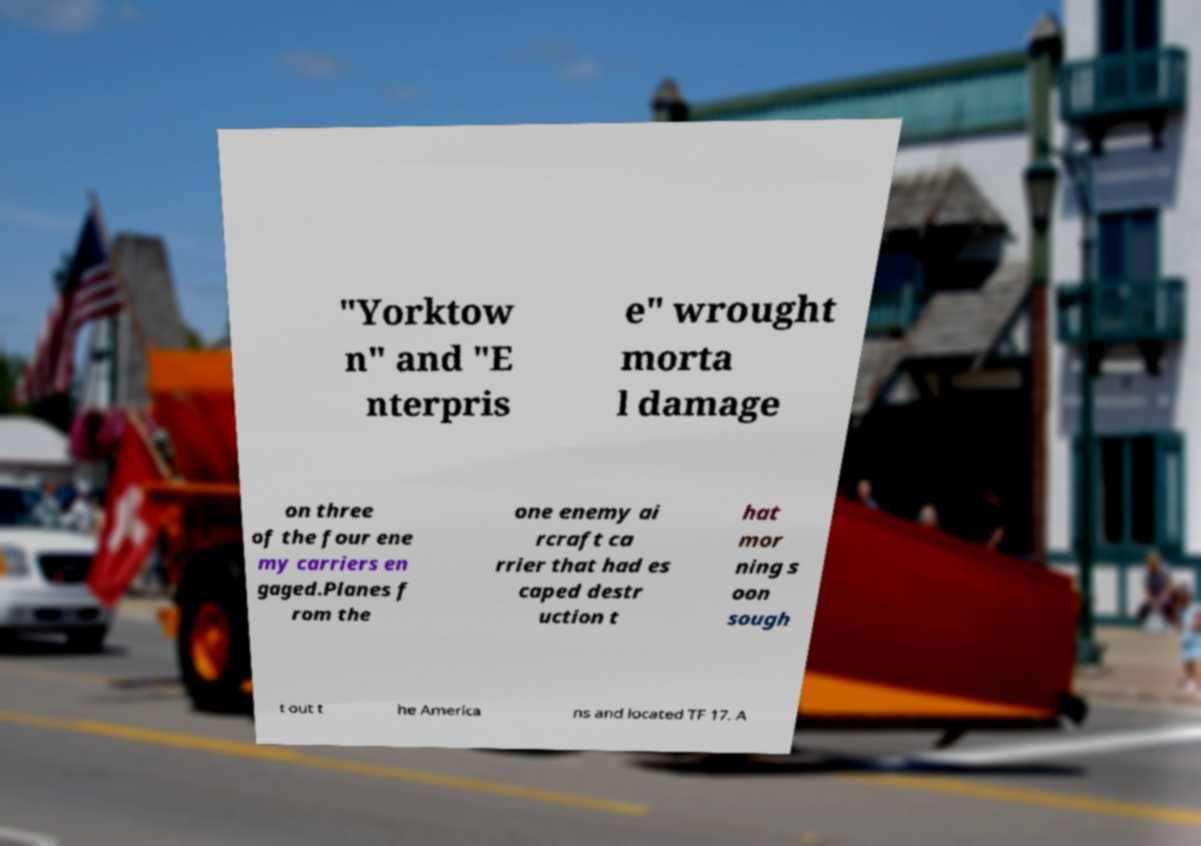For documentation purposes, I need the text within this image transcribed. Could you provide that? "Yorktow n" and "E nterpris e" wrought morta l damage on three of the four ene my carriers en gaged.Planes f rom the one enemy ai rcraft ca rrier that had es caped destr uction t hat mor ning s oon sough t out t he America ns and located TF 17. A 